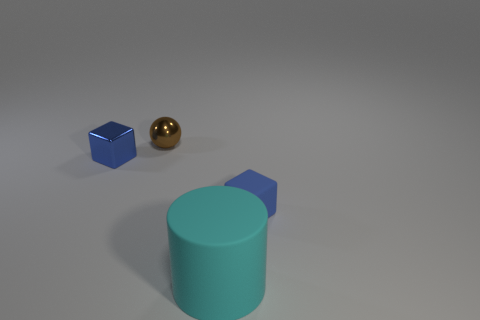Add 1 cylinders. How many objects exist? 5 Subtract all balls. How many objects are left? 3 Add 4 metal spheres. How many metal spheres exist? 5 Subtract 0 brown blocks. How many objects are left? 4 Subtract all blue metal things. Subtract all small things. How many objects are left? 0 Add 3 tiny metallic spheres. How many tiny metallic spheres are left? 4 